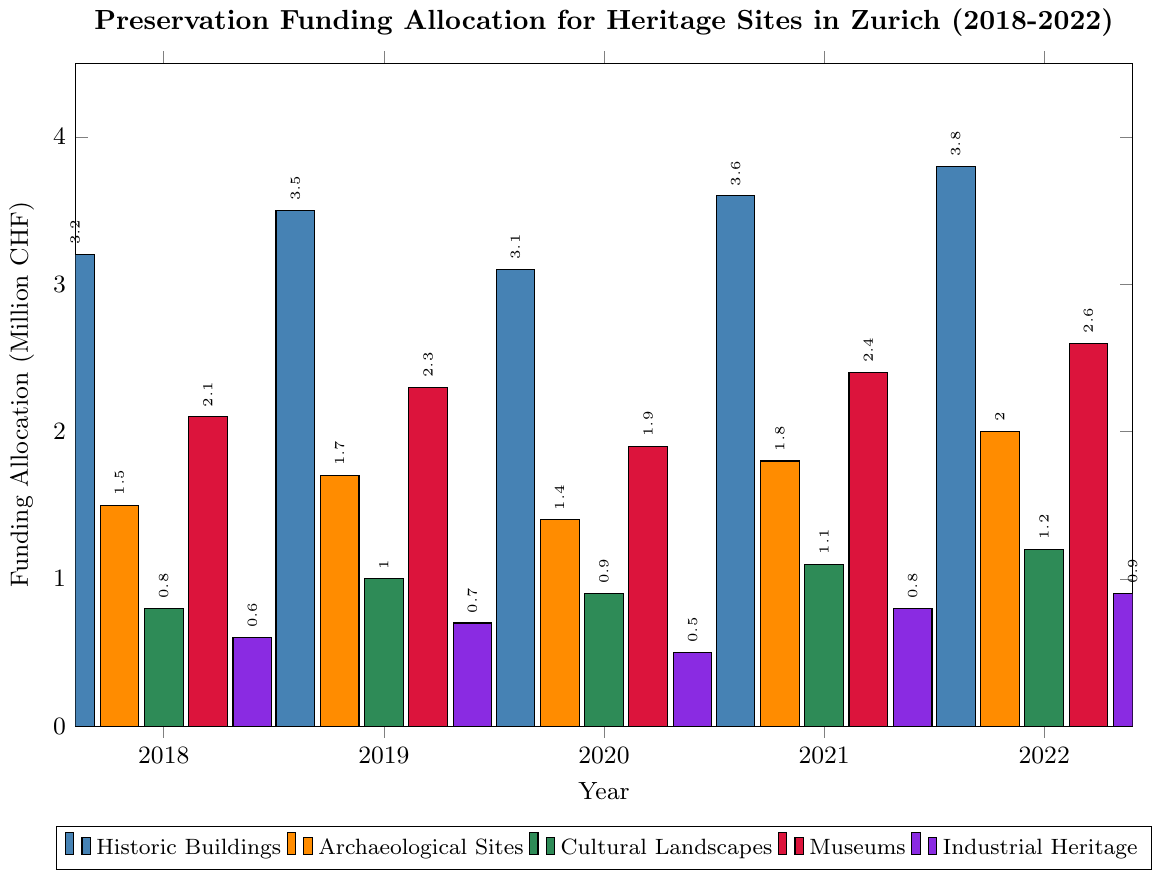Which type of heritage site received the highest funding allocation in 2022? To find the type with the highest funding in 2022, we look at the heights of the bars labeled with the year 2022. The highest bar is 3.8, which corresponds to Historic Buildings.
Answer: Historic Buildings How much more funding did Museums receive in 2021 compared to 2020? In 2020, the funding for Museums was 1.9 million CHF, and in 2021, it was 2.4 million CHF. The difference is 2.4 - 1.9.
Answer: 0.5 million CHF What is the average yearly funding allocation for Archaeological Sites over the 5 years? Sum the funding for Archaeological Sites from 2018 to 2022: 1.5 + 1.7 + 1.4 + 1.8 + 2.0 = 8.4. Divide by 5 years: 8.4 / 5.
Answer: 1.68 million CHF Which type of heritage site had the lowest funding allocation in 2020? In 2020, the lowest bar corresponds to 0.5 million CHF, which represents Industrial Heritage.
Answer: Industrial Heritage Was the funding allocation for Cultural Landscapes higher or lower in 2019 compared to 2020? In 2019, funding for Cultural Landscapes was 1.0 million CHF, and in 2020, it was 0.9 million CHF. 1.0 is higher than 0.9.
Answer: Higher How much did the funding for Historic Buildings increase from 2019 to 2022? Funding for Historic Buildings in 2019 was 3.5 million CHF, and in 2022 it was 3.8 million CHF. The increase is 3.8 - 3.5.
Answer: 0.3 million CHF Which type of heritage site had the most consistent funding allocation over the years? By visually comparing the heights of the bars for each heritage site type, Museums seem to have consistently close values from 2.1 to 2.6 million CHF.
Answer: Museums What is the total funding allocated to Industrial Heritage over the 5 years? Sum the funding for Industrial Heritage from 2018 to 2022: 0.6 + 0.7 + 0.5 + 0.8 + 0.9 = 3.5 million CHF.
Answer: 3.5 million CHF 